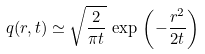Convert formula to latex. <formula><loc_0><loc_0><loc_500><loc_500>q ( r , t ) \simeq \sqrt { \frac { 2 } { \pi t } } \, \exp \, \left ( - \frac { r ^ { 2 } } { 2 t } \right )</formula> 